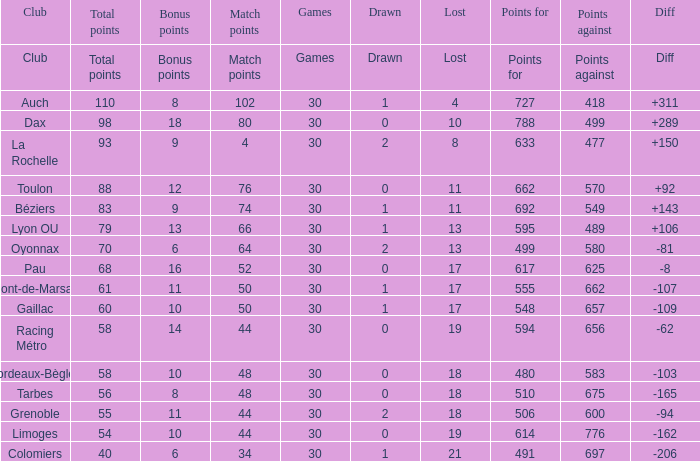What is the worth of match points when the score is 570? 76.0. 